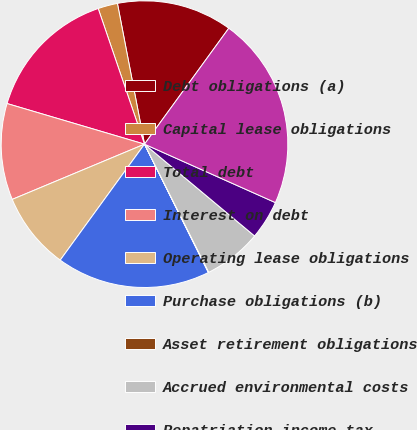Convert chart. <chart><loc_0><loc_0><loc_500><loc_500><pie_chart><fcel>Debt obligations (a)<fcel>Capital lease obligations<fcel>Total debt<fcel>Interest on debt<fcel>Operating lease obligations<fcel>Purchase obligations (b)<fcel>Asset retirement obligations<fcel>Accrued environmental costs<fcel>Repatriation income tax<fcel>Total<nl><fcel>13.03%<fcel>2.21%<fcel>15.19%<fcel>10.87%<fcel>8.7%<fcel>17.35%<fcel>0.05%<fcel>6.54%<fcel>4.38%<fcel>21.68%<nl></chart> 